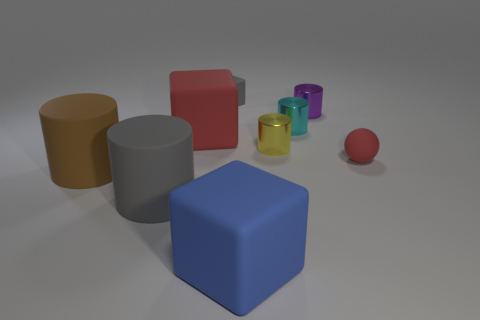Subtract all cyan cylinders. How many cylinders are left? 4 Subtract 2 cylinders. How many cylinders are left? 3 Subtract all gray blocks. How many blocks are left? 2 Subtract 1 blue blocks. How many objects are left? 8 Subtract all blocks. How many objects are left? 6 Subtract all green balls. Subtract all brown blocks. How many balls are left? 1 Subtract all small cyan things. Subtract all gray cylinders. How many objects are left? 7 Add 3 tiny purple metal things. How many tiny purple metal things are left? 4 Add 1 tiny yellow shiny cylinders. How many tiny yellow shiny cylinders exist? 2 